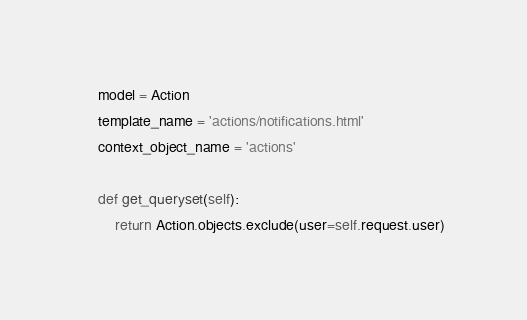<code> <loc_0><loc_0><loc_500><loc_500><_Python_>    model = Action
    template_name = 'actions/notifications.html'
    context_object_name = 'actions'

    def get_queryset(self):
        return Action.objects.exclude(user=self.request.user)
</code> 